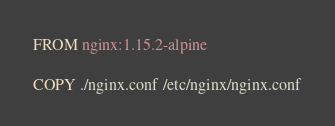<code> <loc_0><loc_0><loc_500><loc_500><_Dockerfile_>FROM nginx:1.15.2-alpine

COPY ./nginx.conf /etc/nginx/nginx.conf
</code> 